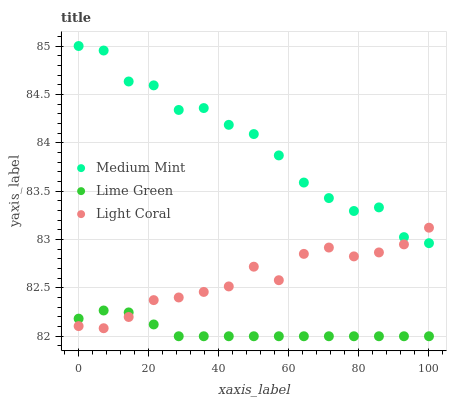Does Lime Green have the minimum area under the curve?
Answer yes or no. Yes. Does Medium Mint have the maximum area under the curve?
Answer yes or no. Yes. Does Light Coral have the minimum area under the curve?
Answer yes or no. No. Does Light Coral have the maximum area under the curve?
Answer yes or no. No. Is Lime Green the smoothest?
Answer yes or no. Yes. Is Medium Mint the roughest?
Answer yes or no. Yes. Is Light Coral the smoothest?
Answer yes or no. No. Is Light Coral the roughest?
Answer yes or no. No. Does Lime Green have the lowest value?
Answer yes or no. Yes. Does Light Coral have the lowest value?
Answer yes or no. No. Does Medium Mint have the highest value?
Answer yes or no. Yes. Does Light Coral have the highest value?
Answer yes or no. No. Is Lime Green less than Medium Mint?
Answer yes or no. Yes. Is Medium Mint greater than Lime Green?
Answer yes or no. Yes. Does Lime Green intersect Light Coral?
Answer yes or no. Yes. Is Lime Green less than Light Coral?
Answer yes or no. No. Is Lime Green greater than Light Coral?
Answer yes or no. No. Does Lime Green intersect Medium Mint?
Answer yes or no. No. 